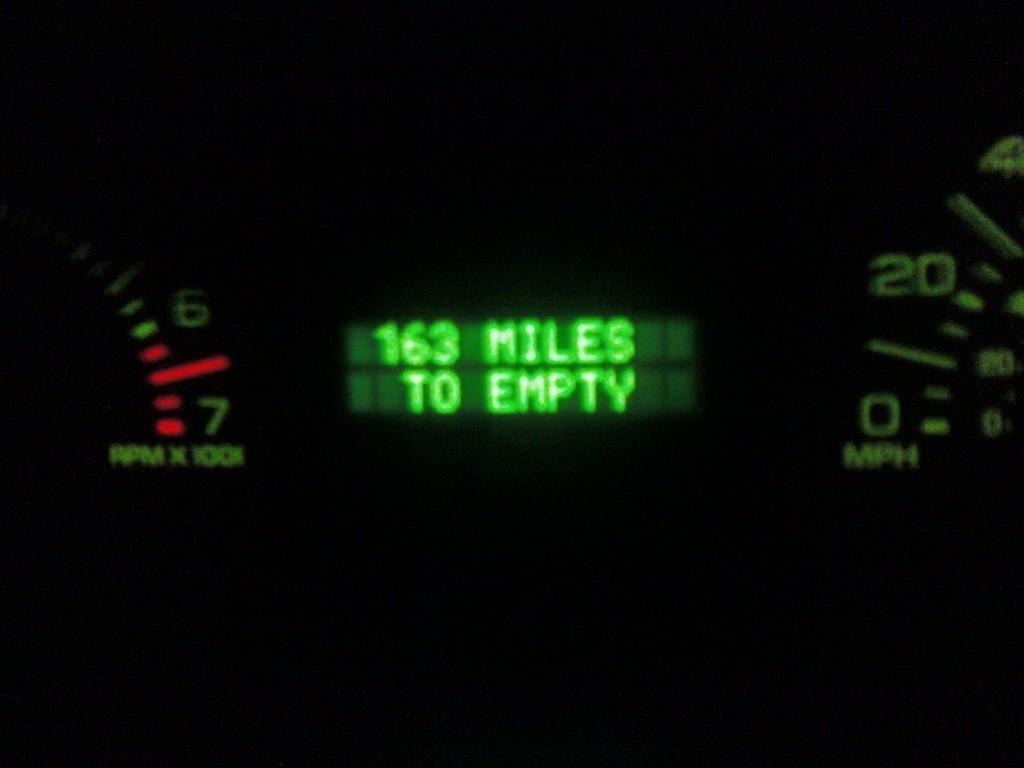In one or two sentences, can you explain what this image depicts? As we can see in the image there is speedometer. 